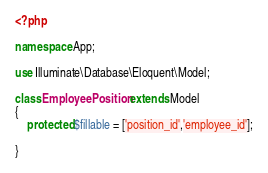<code> <loc_0><loc_0><loc_500><loc_500><_PHP_><?php

namespace App;

use Illuminate\Database\Eloquent\Model;

class EmployeePosition extends Model
{
    protected $fillable = ['position_id','employee_id'];

}
</code> 